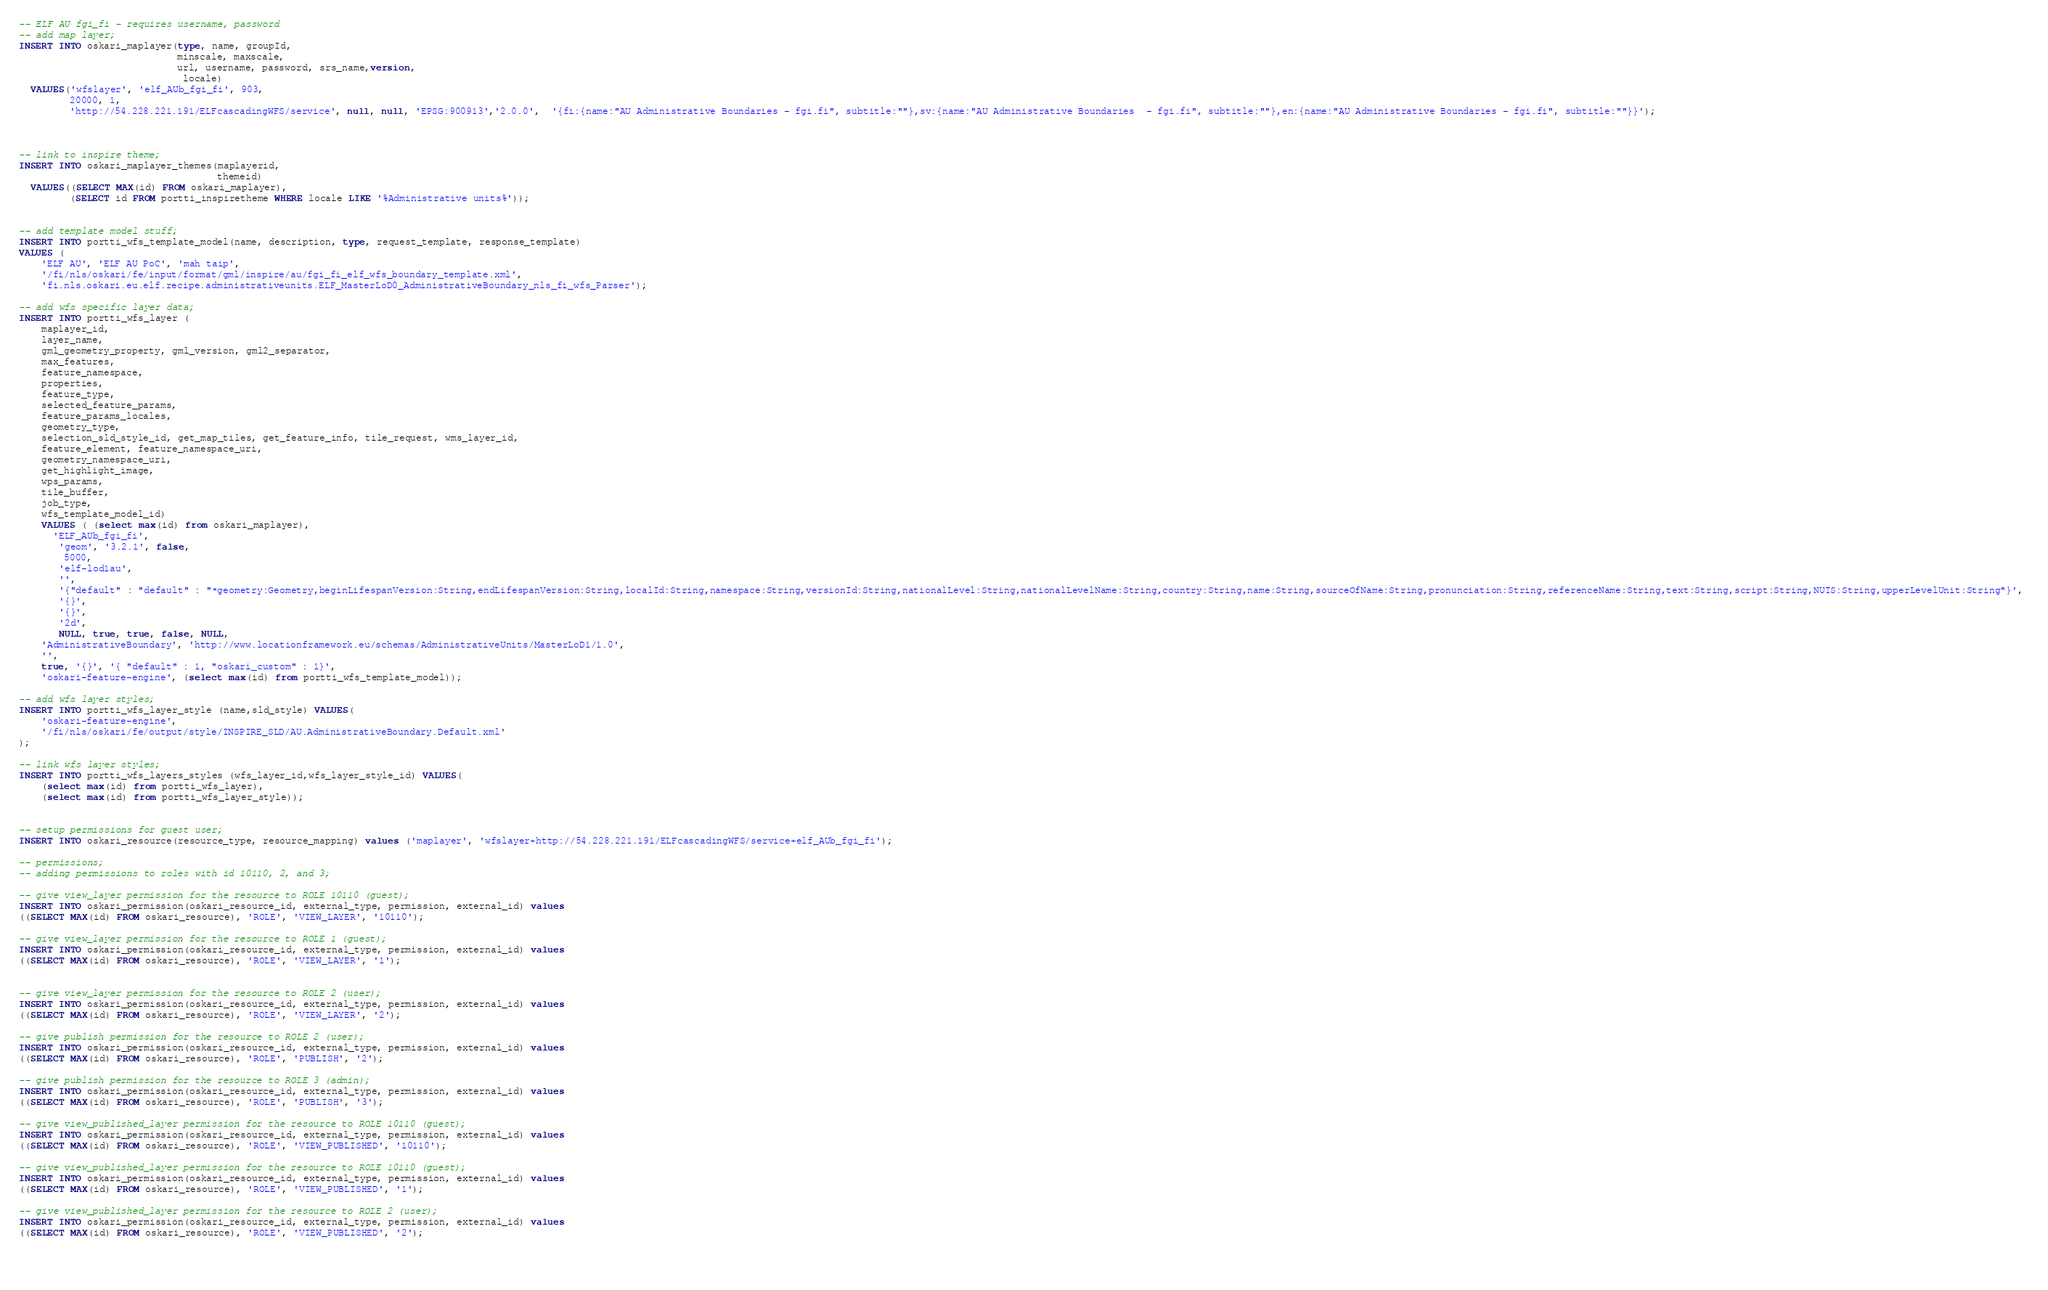<code> <loc_0><loc_0><loc_500><loc_500><_SQL_>-- ELF AU fgi_fi - requires username, password
-- add map layer; 
INSERT INTO oskari_maplayer(type, name, groupId, 
                            minscale, maxscale, 
                            url, username, password, srs_name,version, 
                             locale) 
  VALUES('wfslayer', 'elf_AUb_fgi_fi', 903, 
         20000, 1, 
         'http://54.228.221.191/ELFcascadingWFS/service', null, null, 'EPSG:900913','2.0.0',  '{fi:{name:"AU Administrative Boundaries - fgi.fi", subtitle:""},sv:{name:"AU Administrative Boundaries  - fgi.fi", subtitle:""},en:{name:"AU Administrative Boundaries - fgi.fi", subtitle:""}}');
         

         
-- link to inspire theme; 
INSERT INTO oskari_maplayer_themes(maplayerid, 
                                   themeid) 
  VALUES((SELECT MAX(id) FROM oskari_maplayer), 
         (SELECT id FROM portti_inspiretheme WHERE locale LIKE '%Administrative units%')); 
         
         
-- add template model stuff;
INSERT INTO portti_wfs_template_model(name, description, type, request_template, response_template) 
VALUES (
	'ELF AU', 'ELF AU PoC', 'mah taip', 
	'/fi/nls/oskari/fe/input/format/gml/inspire/au/fgi_fi_elf_wfs_boundary_template.xml', 
	'fi.nls.oskari.eu.elf.recipe.administrativeunits.ELF_MasterLoD0_AdministrativeBoundary_nls_fi_wfs_Parser');          

-- add wfs specific layer data; 
INSERT INTO portti_wfs_layer ( 
    maplayer_id, 
    layer_name, 
    gml_geometry_property, gml_version, gml2_separator, 
    max_features, 
    feature_namespace, 
    properties, 
    feature_type, 
    selected_feature_params, 
    feature_params_locales, 
    geometry_type, 
    selection_sld_style_id, get_map_tiles, get_feature_info, tile_request, wms_layer_id, 
    feature_element, feature_namespace_uri, 
    geometry_namespace_uri, 
    get_highlight_image, 
    wps_params, 
    tile_buffer, 
    job_type, 
    wfs_template_model_id) 
    VALUES ( (select max(id) from oskari_maplayer), 
      'ELF_AUb_fgi_fi', 
       'geom', '3.2.1', false, 
        5000, 
       'elf-lod1au', 
       '', 
       '{"default" : "default" : "*geometry:Geometry,beginLifespanVersion:String,endLifespanVersion:String,localId:String,namespace:String,versionId:String,nationalLevel:String,nationalLevelName:String,country:String,name:String,sourceOfName:String,pronunciation:String,referenceName:String,text:String,script:String,NUTS:String,upperLevelUnit:String"}', 
       '{}', 
       '{}', 
       '2d', 
       NULL, true, true, false, NULL, 
	'AdministrativeBoundary', 'http://www.locationframework.eu/schemas/AdministrativeUnits/MasterLoD1/1.0', 
	'', 
	true, '{}', '{ "default" : 1, "oskari_custom" : 1}', 
	'oskari-feature-engine', (select max(id) from portti_wfs_template_model)); 
	
-- add wfs layer styles; 
INSERT INTO portti_wfs_layer_style (name,sld_style) VALUES(
	'oskari-feature-engine',
	'/fi/nls/oskari/fe/output/style/INSPIRE_SLD/AU.AdministrativeBoundary.Default.xml'
);

-- link wfs layer styles; 
INSERT INTO portti_wfs_layers_styles (wfs_layer_id,wfs_layer_style_id) VALUES(
	(select max(id) from portti_wfs_layer),
	(select max(id) from portti_wfs_layer_style));
	

-- setup permissions for guest user;
INSERT INTO oskari_resource(resource_type, resource_mapping) values ('maplayer', 'wfslayer+http://54.228.221.191/ELFcascadingWFS/service+elf_AUb_fgi_fi');

-- permissions;
-- adding permissions to roles with id 10110, 2, and 3;

-- give view_layer permission for the resource to ROLE 10110 (guest);
INSERT INTO oskari_permission(oskari_resource_id, external_type, permission, external_id) values
((SELECT MAX(id) FROM oskari_resource), 'ROLE', 'VIEW_LAYER', '10110');

-- give view_layer permission for the resource to ROLE 1 (guest);
INSERT INTO oskari_permission(oskari_resource_id, external_type, permission, external_id) values
((SELECT MAX(id) FROM oskari_resource), 'ROLE', 'VIEW_LAYER', '1');


-- give view_layer permission for the resource to ROLE 2 (user);
INSERT INTO oskari_permission(oskari_resource_id, external_type, permission, external_id) values
((SELECT MAX(id) FROM oskari_resource), 'ROLE', 'VIEW_LAYER', '2');

-- give publish permission for the resource to ROLE 2 (user);
INSERT INTO oskari_permission(oskari_resource_id, external_type, permission, external_id) values
((SELECT MAX(id) FROM oskari_resource), 'ROLE', 'PUBLISH', '2');

-- give publish permission for the resource to ROLE 3 (admin);
INSERT INTO oskari_permission(oskari_resource_id, external_type, permission, external_id) values
((SELECT MAX(id) FROM oskari_resource), 'ROLE', 'PUBLISH', '3');

-- give view_published_layer permission for the resource to ROLE 10110 (guest);
INSERT INTO oskari_permission(oskari_resource_id, external_type, permission, external_id) values
((SELECT MAX(id) FROM oskari_resource), 'ROLE', 'VIEW_PUBLISHED', '10110');

-- give view_published_layer permission for the resource to ROLE 10110 (guest);
INSERT INTO oskari_permission(oskari_resource_id, external_type, permission, external_id) values
((SELECT MAX(id) FROM oskari_resource), 'ROLE', 'VIEW_PUBLISHED', '1');

-- give view_published_layer permission for the resource to ROLE 2 (user);
INSERT INTO oskari_permission(oskari_resource_id, external_type, permission, external_id) values
((SELECT MAX(id) FROM oskari_resource), 'ROLE', 'VIEW_PUBLISHED', '2');


	</code> 